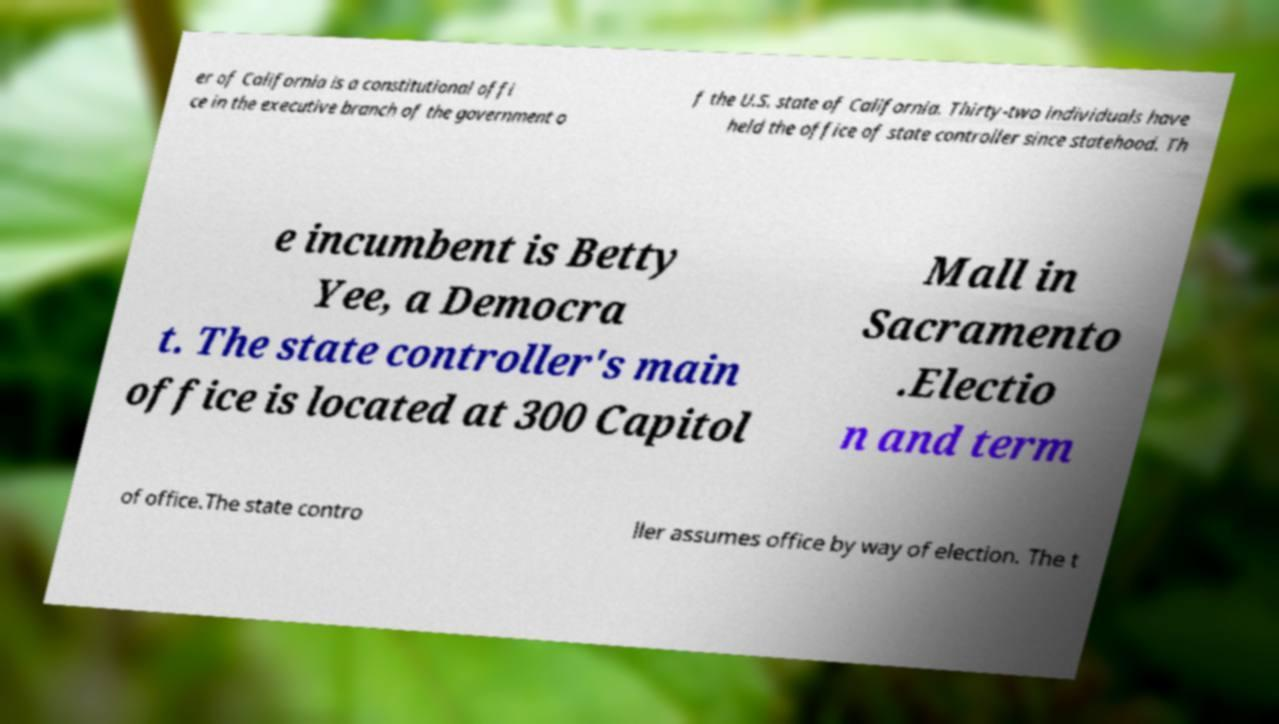Can you read and provide the text displayed in the image?This photo seems to have some interesting text. Can you extract and type it out for me? er of California is a constitutional offi ce in the executive branch of the government o f the U.S. state of California. Thirty-two individuals have held the office of state controller since statehood. Th e incumbent is Betty Yee, a Democra t. The state controller's main office is located at 300 Capitol Mall in Sacramento .Electio n and term of office.The state contro ller assumes office by way of election. The t 